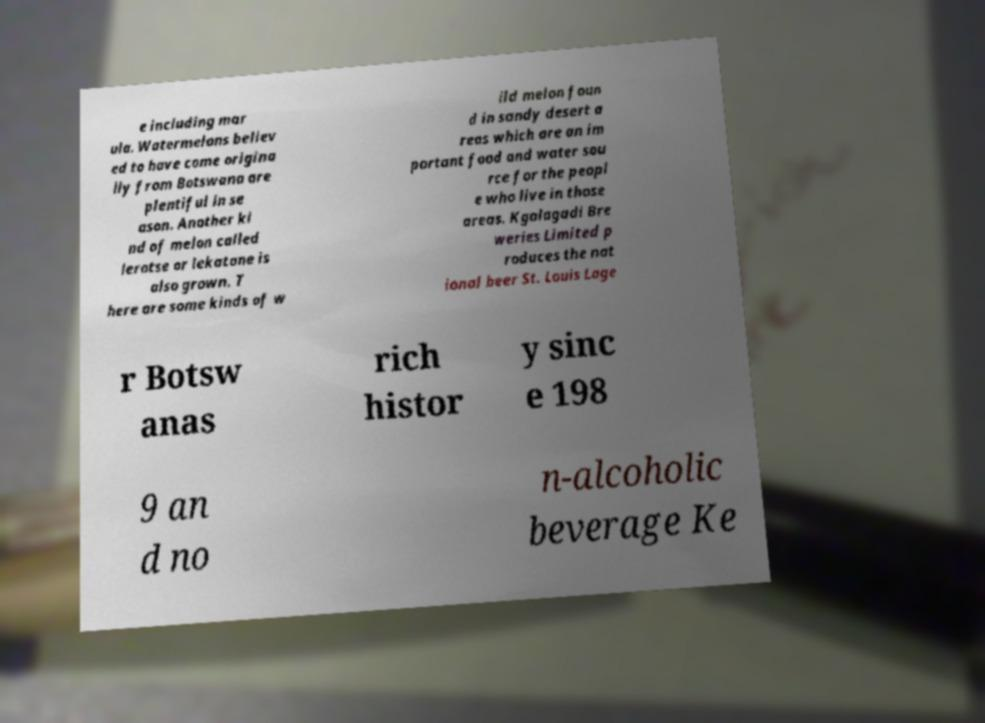Please read and relay the text visible in this image. What does it say? e including mar ula. Watermelons believ ed to have come origina lly from Botswana are plentiful in se ason. Another ki nd of melon called lerotse or lekatane is also grown. T here are some kinds of w ild melon foun d in sandy desert a reas which are an im portant food and water sou rce for the peopl e who live in those areas. Kgalagadi Bre weries Limited p roduces the nat ional beer St. Louis Lage r Botsw anas rich histor y sinc e 198 9 an d no n-alcoholic beverage Ke 